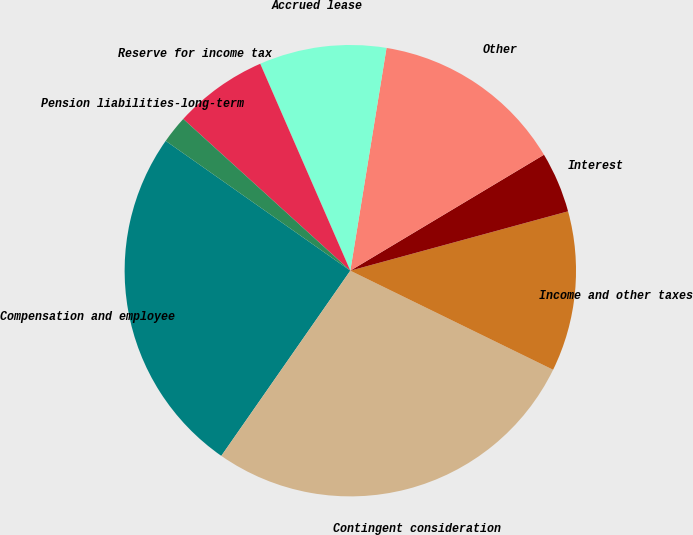<chart> <loc_0><loc_0><loc_500><loc_500><pie_chart><fcel>Compensation and employee<fcel>Contingent consideration<fcel>Income and other taxes<fcel>Interest<fcel>Other<fcel>Accrued lease<fcel>Reserve for income tax<fcel>Pension liabilities-long-term<nl><fcel>25.07%<fcel>27.45%<fcel>11.47%<fcel>4.35%<fcel>13.85%<fcel>9.1%<fcel>6.73%<fcel>1.98%<nl></chart> 